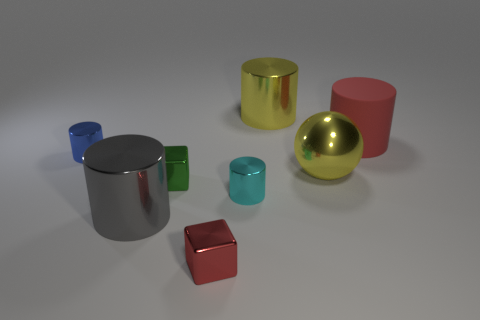There is a red object that is the same size as the sphere; what is it made of?
Offer a terse response. Rubber. There is a large matte thing; is it the same color as the large metallic cylinder that is behind the big red matte thing?
Make the answer very short. No. Is the number of tiny shiny cylinders that are behind the small cyan thing less than the number of big red rubber objects?
Offer a very short reply. No. What number of blue matte cylinders are there?
Ensure brevity in your answer.  0. What is the shape of the red object that is in front of the metal block behind the gray shiny cylinder?
Your response must be concise. Cube. What number of large yellow metallic cylinders are in front of the cyan metallic cylinder?
Offer a very short reply. 0. Is the material of the yellow cylinder the same as the cylinder on the right side of the yellow ball?
Your answer should be compact. No. Is there a yellow metallic object that has the same size as the yellow cylinder?
Your answer should be very brief. Yes. Is the number of small cyan metal objects that are right of the large red rubber thing the same as the number of big rubber things?
Give a very brief answer. No. The gray cylinder has what size?
Offer a terse response. Large. 